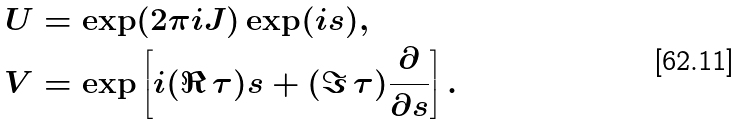<formula> <loc_0><loc_0><loc_500><loc_500>U & = \exp ( 2 \pi i J ) \exp ( i s ) , \\ V & = \exp \left [ i ( \Re \, \tau ) s + ( \Im \, \tau ) \frac { \partial } { \partial s } \right ] .</formula> 